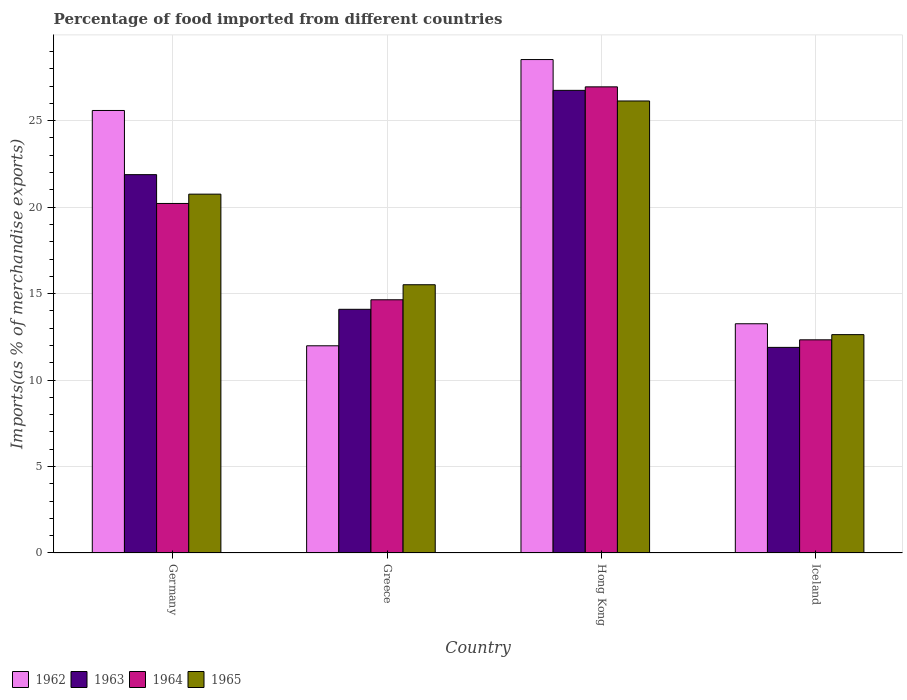How many different coloured bars are there?
Your response must be concise. 4. How many groups of bars are there?
Offer a very short reply. 4. Are the number of bars on each tick of the X-axis equal?
Offer a terse response. Yes. How many bars are there on the 2nd tick from the left?
Offer a terse response. 4. How many bars are there on the 3rd tick from the right?
Offer a very short reply. 4. In how many cases, is the number of bars for a given country not equal to the number of legend labels?
Your response must be concise. 0. What is the percentage of imports to different countries in 1965 in Hong Kong?
Ensure brevity in your answer.  26.14. Across all countries, what is the maximum percentage of imports to different countries in 1962?
Ensure brevity in your answer.  28.53. Across all countries, what is the minimum percentage of imports to different countries in 1964?
Your answer should be very brief. 12.33. In which country was the percentage of imports to different countries in 1962 maximum?
Give a very brief answer. Hong Kong. In which country was the percentage of imports to different countries in 1965 minimum?
Offer a very short reply. Iceland. What is the total percentage of imports to different countries in 1964 in the graph?
Provide a succinct answer. 74.14. What is the difference between the percentage of imports to different countries in 1964 in Germany and that in Greece?
Provide a short and direct response. 5.57. What is the difference between the percentage of imports to different countries in 1965 in Greece and the percentage of imports to different countries in 1964 in Hong Kong?
Your answer should be very brief. -11.44. What is the average percentage of imports to different countries in 1965 per country?
Your answer should be compact. 18.76. What is the difference between the percentage of imports to different countries of/in 1963 and percentage of imports to different countries of/in 1962 in Iceland?
Offer a very short reply. -1.37. What is the ratio of the percentage of imports to different countries in 1964 in Germany to that in Hong Kong?
Make the answer very short. 0.75. Is the percentage of imports to different countries in 1964 in Germany less than that in Iceland?
Provide a short and direct response. No. What is the difference between the highest and the second highest percentage of imports to different countries in 1964?
Your answer should be compact. 6.74. What is the difference between the highest and the lowest percentage of imports to different countries in 1964?
Your response must be concise. 14.63. In how many countries, is the percentage of imports to different countries in 1965 greater than the average percentage of imports to different countries in 1965 taken over all countries?
Provide a succinct answer. 2. Is the sum of the percentage of imports to different countries in 1964 in Germany and Hong Kong greater than the maximum percentage of imports to different countries in 1963 across all countries?
Your response must be concise. Yes. What does the 2nd bar from the left in Hong Kong represents?
Your response must be concise. 1963. What does the 2nd bar from the right in Hong Kong represents?
Your answer should be compact. 1964. Is it the case that in every country, the sum of the percentage of imports to different countries in 1963 and percentage of imports to different countries in 1965 is greater than the percentage of imports to different countries in 1962?
Your answer should be compact. Yes. Are all the bars in the graph horizontal?
Ensure brevity in your answer.  No. How many countries are there in the graph?
Your answer should be very brief. 4. What is the difference between two consecutive major ticks on the Y-axis?
Make the answer very short. 5. Does the graph contain any zero values?
Make the answer very short. No. Does the graph contain grids?
Offer a very short reply. Yes. Where does the legend appear in the graph?
Provide a succinct answer. Bottom left. How are the legend labels stacked?
Offer a very short reply. Horizontal. What is the title of the graph?
Your answer should be very brief. Percentage of food imported from different countries. Does "1978" appear as one of the legend labels in the graph?
Offer a very short reply. No. What is the label or title of the Y-axis?
Keep it short and to the point. Imports(as % of merchandise exports). What is the Imports(as % of merchandise exports) in 1962 in Germany?
Your answer should be compact. 25.59. What is the Imports(as % of merchandise exports) of 1963 in Germany?
Your response must be concise. 21.88. What is the Imports(as % of merchandise exports) in 1964 in Germany?
Offer a terse response. 20.21. What is the Imports(as % of merchandise exports) in 1965 in Germany?
Offer a terse response. 20.75. What is the Imports(as % of merchandise exports) of 1962 in Greece?
Offer a terse response. 11.98. What is the Imports(as % of merchandise exports) of 1963 in Greece?
Your response must be concise. 14.09. What is the Imports(as % of merchandise exports) in 1964 in Greece?
Make the answer very short. 14.64. What is the Imports(as % of merchandise exports) of 1965 in Greece?
Keep it short and to the point. 15.51. What is the Imports(as % of merchandise exports) in 1962 in Hong Kong?
Your answer should be compact. 28.53. What is the Imports(as % of merchandise exports) in 1963 in Hong Kong?
Ensure brevity in your answer.  26.75. What is the Imports(as % of merchandise exports) of 1964 in Hong Kong?
Provide a short and direct response. 26.96. What is the Imports(as % of merchandise exports) in 1965 in Hong Kong?
Give a very brief answer. 26.14. What is the Imports(as % of merchandise exports) in 1962 in Iceland?
Provide a succinct answer. 13.26. What is the Imports(as % of merchandise exports) of 1963 in Iceland?
Your answer should be compact. 11.89. What is the Imports(as % of merchandise exports) in 1964 in Iceland?
Keep it short and to the point. 12.33. What is the Imports(as % of merchandise exports) in 1965 in Iceland?
Your response must be concise. 12.63. Across all countries, what is the maximum Imports(as % of merchandise exports) of 1962?
Your answer should be very brief. 28.53. Across all countries, what is the maximum Imports(as % of merchandise exports) in 1963?
Ensure brevity in your answer.  26.75. Across all countries, what is the maximum Imports(as % of merchandise exports) in 1964?
Provide a short and direct response. 26.96. Across all countries, what is the maximum Imports(as % of merchandise exports) in 1965?
Make the answer very short. 26.14. Across all countries, what is the minimum Imports(as % of merchandise exports) of 1962?
Make the answer very short. 11.98. Across all countries, what is the minimum Imports(as % of merchandise exports) in 1963?
Offer a terse response. 11.89. Across all countries, what is the minimum Imports(as % of merchandise exports) in 1964?
Offer a very short reply. 12.33. Across all countries, what is the minimum Imports(as % of merchandise exports) of 1965?
Offer a terse response. 12.63. What is the total Imports(as % of merchandise exports) of 1962 in the graph?
Offer a terse response. 79.36. What is the total Imports(as % of merchandise exports) of 1963 in the graph?
Offer a terse response. 74.61. What is the total Imports(as % of merchandise exports) of 1964 in the graph?
Your response must be concise. 74.14. What is the total Imports(as % of merchandise exports) of 1965 in the graph?
Give a very brief answer. 75.03. What is the difference between the Imports(as % of merchandise exports) in 1962 in Germany and that in Greece?
Your answer should be very brief. 13.61. What is the difference between the Imports(as % of merchandise exports) in 1963 in Germany and that in Greece?
Offer a terse response. 7.79. What is the difference between the Imports(as % of merchandise exports) of 1964 in Germany and that in Greece?
Provide a short and direct response. 5.57. What is the difference between the Imports(as % of merchandise exports) in 1965 in Germany and that in Greece?
Keep it short and to the point. 5.24. What is the difference between the Imports(as % of merchandise exports) of 1962 in Germany and that in Hong Kong?
Provide a short and direct response. -2.95. What is the difference between the Imports(as % of merchandise exports) in 1963 in Germany and that in Hong Kong?
Give a very brief answer. -4.87. What is the difference between the Imports(as % of merchandise exports) in 1964 in Germany and that in Hong Kong?
Provide a short and direct response. -6.74. What is the difference between the Imports(as % of merchandise exports) of 1965 in Germany and that in Hong Kong?
Provide a short and direct response. -5.39. What is the difference between the Imports(as % of merchandise exports) of 1962 in Germany and that in Iceland?
Provide a short and direct response. 12.33. What is the difference between the Imports(as % of merchandise exports) of 1963 in Germany and that in Iceland?
Your answer should be compact. 9.99. What is the difference between the Imports(as % of merchandise exports) of 1964 in Germany and that in Iceland?
Offer a terse response. 7.89. What is the difference between the Imports(as % of merchandise exports) in 1965 in Germany and that in Iceland?
Give a very brief answer. 8.12. What is the difference between the Imports(as % of merchandise exports) in 1962 in Greece and that in Hong Kong?
Provide a succinct answer. -16.55. What is the difference between the Imports(as % of merchandise exports) of 1963 in Greece and that in Hong Kong?
Your answer should be very brief. -12.66. What is the difference between the Imports(as % of merchandise exports) of 1964 in Greece and that in Hong Kong?
Your response must be concise. -12.31. What is the difference between the Imports(as % of merchandise exports) in 1965 in Greece and that in Hong Kong?
Offer a very short reply. -10.63. What is the difference between the Imports(as % of merchandise exports) in 1962 in Greece and that in Iceland?
Give a very brief answer. -1.27. What is the difference between the Imports(as % of merchandise exports) in 1963 in Greece and that in Iceland?
Provide a succinct answer. 2.2. What is the difference between the Imports(as % of merchandise exports) of 1964 in Greece and that in Iceland?
Make the answer very short. 2.32. What is the difference between the Imports(as % of merchandise exports) in 1965 in Greece and that in Iceland?
Your answer should be very brief. 2.88. What is the difference between the Imports(as % of merchandise exports) of 1962 in Hong Kong and that in Iceland?
Ensure brevity in your answer.  15.28. What is the difference between the Imports(as % of merchandise exports) of 1963 in Hong Kong and that in Iceland?
Make the answer very short. 14.86. What is the difference between the Imports(as % of merchandise exports) of 1964 in Hong Kong and that in Iceland?
Give a very brief answer. 14.63. What is the difference between the Imports(as % of merchandise exports) in 1965 in Hong Kong and that in Iceland?
Offer a terse response. 13.51. What is the difference between the Imports(as % of merchandise exports) of 1962 in Germany and the Imports(as % of merchandise exports) of 1963 in Greece?
Provide a succinct answer. 11.5. What is the difference between the Imports(as % of merchandise exports) in 1962 in Germany and the Imports(as % of merchandise exports) in 1964 in Greece?
Make the answer very short. 10.95. What is the difference between the Imports(as % of merchandise exports) of 1962 in Germany and the Imports(as % of merchandise exports) of 1965 in Greece?
Your answer should be very brief. 10.08. What is the difference between the Imports(as % of merchandise exports) in 1963 in Germany and the Imports(as % of merchandise exports) in 1964 in Greece?
Make the answer very short. 7.24. What is the difference between the Imports(as % of merchandise exports) of 1963 in Germany and the Imports(as % of merchandise exports) of 1965 in Greece?
Your answer should be compact. 6.37. What is the difference between the Imports(as % of merchandise exports) in 1964 in Germany and the Imports(as % of merchandise exports) in 1965 in Greece?
Offer a very short reply. 4.7. What is the difference between the Imports(as % of merchandise exports) of 1962 in Germany and the Imports(as % of merchandise exports) of 1963 in Hong Kong?
Make the answer very short. -1.16. What is the difference between the Imports(as % of merchandise exports) of 1962 in Germany and the Imports(as % of merchandise exports) of 1964 in Hong Kong?
Your answer should be compact. -1.37. What is the difference between the Imports(as % of merchandise exports) of 1962 in Germany and the Imports(as % of merchandise exports) of 1965 in Hong Kong?
Offer a terse response. -0.55. What is the difference between the Imports(as % of merchandise exports) in 1963 in Germany and the Imports(as % of merchandise exports) in 1964 in Hong Kong?
Make the answer very short. -5.08. What is the difference between the Imports(as % of merchandise exports) in 1963 in Germany and the Imports(as % of merchandise exports) in 1965 in Hong Kong?
Give a very brief answer. -4.26. What is the difference between the Imports(as % of merchandise exports) of 1964 in Germany and the Imports(as % of merchandise exports) of 1965 in Hong Kong?
Your answer should be very brief. -5.93. What is the difference between the Imports(as % of merchandise exports) of 1962 in Germany and the Imports(as % of merchandise exports) of 1963 in Iceland?
Your answer should be compact. 13.7. What is the difference between the Imports(as % of merchandise exports) of 1962 in Germany and the Imports(as % of merchandise exports) of 1964 in Iceland?
Provide a succinct answer. 13.26. What is the difference between the Imports(as % of merchandise exports) in 1962 in Germany and the Imports(as % of merchandise exports) in 1965 in Iceland?
Provide a short and direct response. 12.96. What is the difference between the Imports(as % of merchandise exports) of 1963 in Germany and the Imports(as % of merchandise exports) of 1964 in Iceland?
Your answer should be compact. 9.55. What is the difference between the Imports(as % of merchandise exports) of 1963 in Germany and the Imports(as % of merchandise exports) of 1965 in Iceland?
Provide a short and direct response. 9.25. What is the difference between the Imports(as % of merchandise exports) in 1964 in Germany and the Imports(as % of merchandise exports) in 1965 in Iceland?
Give a very brief answer. 7.59. What is the difference between the Imports(as % of merchandise exports) of 1962 in Greece and the Imports(as % of merchandise exports) of 1963 in Hong Kong?
Keep it short and to the point. -14.77. What is the difference between the Imports(as % of merchandise exports) in 1962 in Greece and the Imports(as % of merchandise exports) in 1964 in Hong Kong?
Offer a very short reply. -14.97. What is the difference between the Imports(as % of merchandise exports) of 1962 in Greece and the Imports(as % of merchandise exports) of 1965 in Hong Kong?
Ensure brevity in your answer.  -14.16. What is the difference between the Imports(as % of merchandise exports) in 1963 in Greece and the Imports(as % of merchandise exports) in 1964 in Hong Kong?
Give a very brief answer. -12.86. What is the difference between the Imports(as % of merchandise exports) in 1963 in Greece and the Imports(as % of merchandise exports) in 1965 in Hong Kong?
Your answer should be compact. -12.05. What is the difference between the Imports(as % of merchandise exports) of 1964 in Greece and the Imports(as % of merchandise exports) of 1965 in Hong Kong?
Offer a terse response. -11.5. What is the difference between the Imports(as % of merchandise exports) in 1962 in Greece and the Imports(as % of merchandise exports) in 1963 in Iceland?
Provide a short and direct response. 0.09. What is the difference between the Imports(as % of merchandise exports) in 1962 in Greece and the Imports(as % of merchandise exports) in 1964 in Iceland?
Your answer should be very brief. -0.35. What is the difference between the Imports(as % of merchandise exports) of 1962 in Greece and the Imports(as % of merchandise exports) of 1965 in Iceland?
Your answer should be very brief. -0.65. What is the difference between the Imports(as % of merchandise exports) in 1963 in Greece and the Imports(as % of merchandise exports) in 1964 in Iceland?
Give a very brief answer. 1.76. What is the difference between the Imports(as % of merchandise exports) in 1963 in Greece and the Imports(as % of merchandise exports) in 1965 in Iceland?
Your answer should be compact. 1.46. What is the difference between the Imports(as % of merchandise exports) of 1964 in Greece and the Imports(as % of merchandise exports) of 1965 in Iceland?
Your answer should be compact. 2.02. What is the difference between the Imports(as % of merchandise exports) in 1962 in Hong Kong and the Imports(as % of merchandise exports) in 1963 in Iceland?
Provide a short and direct response. 16.65. What is the difference between the Imports(as % of merchandise exports) in 1962 in Hong Kong and the Imports(as % of merchandise exports) in 1964 in Iceland?
Provide a short and direct response. 16.21. What is the difference between the Imports(as % of merchandise exports) in 1962 in Hong Kong and the Imports(as % of merchandise exports) in 1965 in Iceland?
Your answer should be compact. 15.91. What is the difference between the Imports(as % of merchandise exports) of 1963 in Hong Kong and the Imports(as % of merchandise exports) of 1964 in Iceland?
Your response must be concise. 14.43. What is the difference between the Imports(as % of merchandise exports) in 1963 in Hong Kong and the Imports(as % of merchandise exports) in 1965 in Iceland?
Keep it short and to the point. 14.13. What is the difference between the Imports(as % of merchandise exports) of 1964 in Hong Kong and the Imports(as % of merchandise exports) of 1965 in Iceland?
Keep it short and to the point. 14.33. What is the average Imports(as % of merchandise exports) in 1962 per country?
Offer a terse response. 19.84. What is the average Imports(as % of merchandise exports) of 1963 per country?
Offer a very short reply. 18.65. What is the average Imports(as % of merchandise exports) of 1964 per country?
Your answer should be compact. 18.53. What is the average Imports(as % of merchandise exports) of 1965 per country?
Your answer should be very brief. 18.76. What is the difference between the Imports(as % of merchandise exports) in 1962 and Imports(as % of merchandise exports) in 1963 in Germany?
Ensure brevity in your answer.  3.71. What is the difference between the Imports(as % of merchandise exports) in 1962 and Imports(as % of merchandise exports) in 1964 in Germany?
Offer a very short reply. 5.38. What is the difference between the Imports(as % of merchandise exports) in 1962 and Imports(as % of merchandise exports) in 1965 in Germany?
Provide a short and direct response. 4.84. What is the difference between the Imports(as % of merchandise exports) of 1963 and Imports(as % of merchandise exports) of 1964 in Germany?
Provide a short and direct response. 1.67. What is the difference between the Imports(as % of merchandise exports) in 1963 and Imports(as % of merchandise exports) in 1965 in Germany?
Your response must be concise. 1.13. What is the difference between the Imports(as % of merchandise exports) of 1964 and Imports(as % of merchandise exports) of 1965 in Germany?
Offer a terse response. -0.54. What is the difference between the Imports(as % of merchandise exports) of 1962 and Imports(as % of merchandise exports) of 1963 in Greece?
Make the answer very short. -2.11. What is the difference between the Imports(as % of merchandise exports) of 1962 and Imports(as % of merchandise exports) of 1964 in Greece?
Offer a terse response. -2.66. What is the difference between the Imports(as % of merchandise exports) of 1962 and Imports(as % of merchandise exports) of 1965 in Greece?
Your answer should be compact. -3.53. What is the difference between the Imports(as % of merchandise exports) in 1963 and Imports(as % of merchandise exports) in 1964 in Greece?
Your answer should be compact. -0.55. What is the difference between the Imports(as % of merchandise exports) in 1963 and Imports(as % of merchandise exports) in 1965 in Greece?
Your answer should be very brief. -1.42. What is the difference between the Imports(as % of merchandise exports) in 1964 and Imports(as % of merchandise exports) in 1965 in Greece?
Offer a very short reply. -0.87. What is the difference between the Imports(as % of merchandise exports) of 1962 and Imports(as % of merchandise exports) of 1963 in Hong Kong?
Offer a terse response. 1.78. What is the difference between the Imports(as % of merchandise exports) in 1962 and Imports(as % of merchandise exports) in 1964 in Hong Kong?
Your answer should be compact. 1.58. What is the difference between the Imports(as % of merchandise exports) of 1962 and Imports(as % of merchandise exports) of 1965 in Hong Kong?
Give a very brief answer. 2.4. What is the difference between the Imports(as % of merchandise exports) in 1963 and Imports(as % of merchandise exports) in 1964 in Hong Kong?
Make the answer very short. -0.2. What is the difference between the Imports(as % of merchandise exports) in 1963 and Imports(as % of merchandise exports) in 1965 in Hong Kong?
Ensure brevity in your answer.  0.61. What is the difference between the Imports(as % of merchandise exports) of 1964 and Imports(as % of merchandise exports) of 1965 in Hong Kong?
Ensure brevity in your answer.  0.82. What is the difference between the Imports(as % of merchandise exports) in 1962 and Imports(as % of merchandise exports) in 1963 in Iceland?
Your answer should be compact. 1.37. What is the difference between the Imports(as % of merchandise exports) in 1962 and Imports(as % of merchandise exports) in 1964 in Iceland?
Offer a very short reply. 0.93. What is the difference between the Imports(as % of merchandise exports) of 1962 and Imports(as % of merchandise exports) of 1965 in Iceland?
Keep it short and to the point. 0.63. What is the difference between the Imports(as % of merchandise exports) of 1963 and Imports(as % of merchandise exports) of 1964 in Iceland?
Provide a short and direct response. -0.44. What is the difference between the Imports(as % of merchandise exports) in 1963 and Imports(as % of merchandise exports) in 1965 in Iceland?
Your answer should be compact. -0.74. What is the difference between the Imports(as % of merchandise exports) of 1964 and Imports(as % of merchandise exports) of 1965 in Iceland?
Provide a short and direct response. -0.3. What is the ratio of the Imports(as % of merchandise exports) in 1962 in Germany to that in Greece?
Your answer should be compact. 2.14. What is the ratio of the Imports(as % of merchandise exports) of 1963 in Germany to that in Greece?
Give a very brief answer. 1.55. What is the ratio of the Imports(as % of merchandise exports) in 1964 in Germany to that in Greece?
Your response must be concise. 1.38. What is the ratio of the Imports(as % of merchandise exports) of 1965 in Germany to that in Greece?
Your answer should be compact. 1.34. What is the ratio of the Imports(as % of merchandise exports) of 1962 in Germany to that in Hong Kong?
Give a very brief answer. 0.9. What is the ratio of the Imports(as % of merchandise exports) in 1963 in Germany to that in Hong Kong?
Provide a succinct answer. 0.82. What is the ratio of the Imports(as % of merchandise exports) of 1964 in Germany to that in Hong Kong?
Make the answer very short. 0.75. What is the ratio of the Imports(as % of merchandise exports) of 1965 in Germany to that in Hong Kong?
Keep it short and to the point. 0.79. What is the ratio of the Imports(as % of merchandise exports) of 1962 in Germany to that in Iceland?
Keep it short and to the point. 1.93. What is the ratio of the Imports(as % of merchandise exports) of 1963 in Germany to that in Iceland?
Offer a terse response. 1.84. What is the ratio of the Imports(as % of merchandise exports) of 1964 in Germany to that in Iceland?
Offer a terse response. 1.64. What is the ratio of the Imports(as % of merchandise exports) of 1965 in Germany to that in Iceland?
Your answer should be compact. 1.64. What is the ratio of the Imports(as % of merchandise exports) of 1962 in Greece to that in Hong Kong?
Offer a terse response. 0.42. What is the ratio of the Imports(as % of merchandise exports) of 1963 in Greece to that in Hong Kong?
Give a very brief answer. 0.53. What is the ratio of the Imports(as % of merchandise exports) in 1964 in Greece to that in Hong Kong?
Your response must be concise. 0.54. What is the ratio of the Imports(as % of merchandise exports) of 1965 in Greece to that in Hong Kong?
Give a very brief answer. 0.59. What is the ratio of the Imports(as % of merchandise exports) in 1962 in Greece to that in Iceland?
Keep it short and to the point. 0.9. What is the ratio of the Imports(as % of merchandise exports) in 1963 in Greece to that in Iceland?
Ensure brevity in your answer.  1.19. What is the ratio of the Imports(as % of merchandise exports) of 1964 in Greece to that in Iceland?
Your answer should be very brief. 1.19. What is the ratio of the Imports(as % of merchandise exports) of 1965 in Greece to that in Iceland?
Your answer should be compact. 1.23. What is the ratio of the Imports(as % of merchandise exports) of 1962 in Hong Kong to that in Iceland?
Your response must be concise. 2.15. What is the ratio of the Imports(as % of merchandise exports) in 1963 in Hong Kong to that in Iceland?
Your answer should be very brief. 2.25. What is the ratio of the Imports(as % of merchandise exports) of 1964 in Hong Kong to that in Iceland?
Your response must be concise. 2.19. What is the ratio of the Imports(as % of merchandise exports) in 1965 in Hong Kong to that in Iceland?
Provide a succinct answer. 2.07. What is the difference between the highest and the second highest Imports(as % of merchandise exports) of 1962?
Your answer should be compact. 2.95. What is the difference between the highest and the second highest Imports(as % of merchandise exports) in 1963?
Keep it short and to the point. 4.87. What is the difference between the highest and the second highest Imports(as % of merchandise exports) of 1964?
Your response must be concise. 6.74. What is the difference between the highest and the second highest Imports(as % of merchandise exports) of 1965?
Your answer should be compact. 5.39. What is the difference between the highest and the lowest Imports(as % of merchandise exports) in 1962?
Ensure brevity in your answer.  16.55. What is the difference between the highest and the lowest Imports(as % of merchandise exports) of 1963?
Provide a short and direct response. 14.86. What is the difference between the highest and the lowest Imports(as % of merchandise exports) of 1964?
Offer a very short reply. 14.63. What is the difference between the highest and the lowest Imports(as % of merchandise exports) in 1965?
Give a very brief answer. 13.51. 